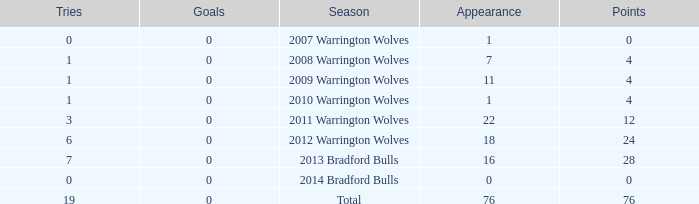How many times is tries 0 and appearance less than 0? 0.0. 